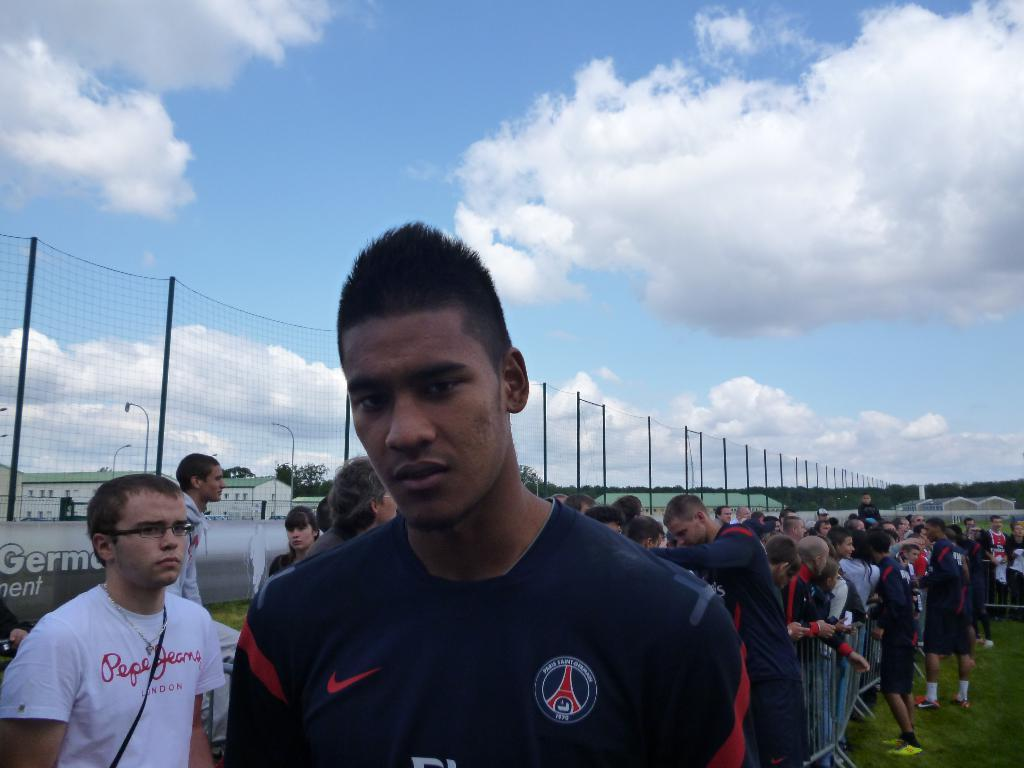How many people are in the image? There are people in the image, but the exact number is not specified. What is one person wearing in the image? One person is wearing a jersey in the image. What can be seen in the background of the image? There is a fence in the background of the image. What is the condition of the sky in the image? The sky is clear in the image. What type of map can be seen in the image? There is no map present in the image. How does the taste of the jersey worn by the person in the image compare to that of a wheel? The taste of the jersey cannot be determined, as it is not an edible item, and there is no wheel present in the image. 